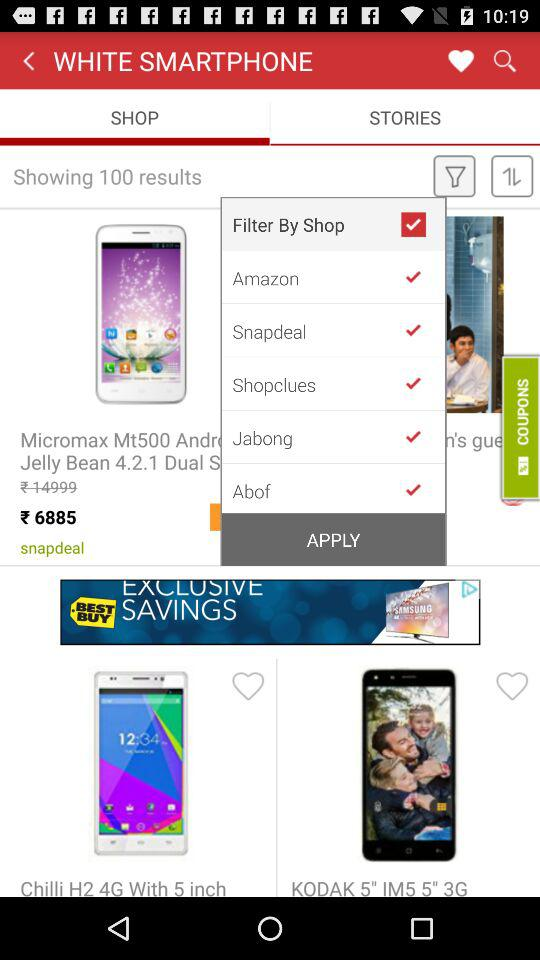Which tab is open? The open tab is "SHOP". 